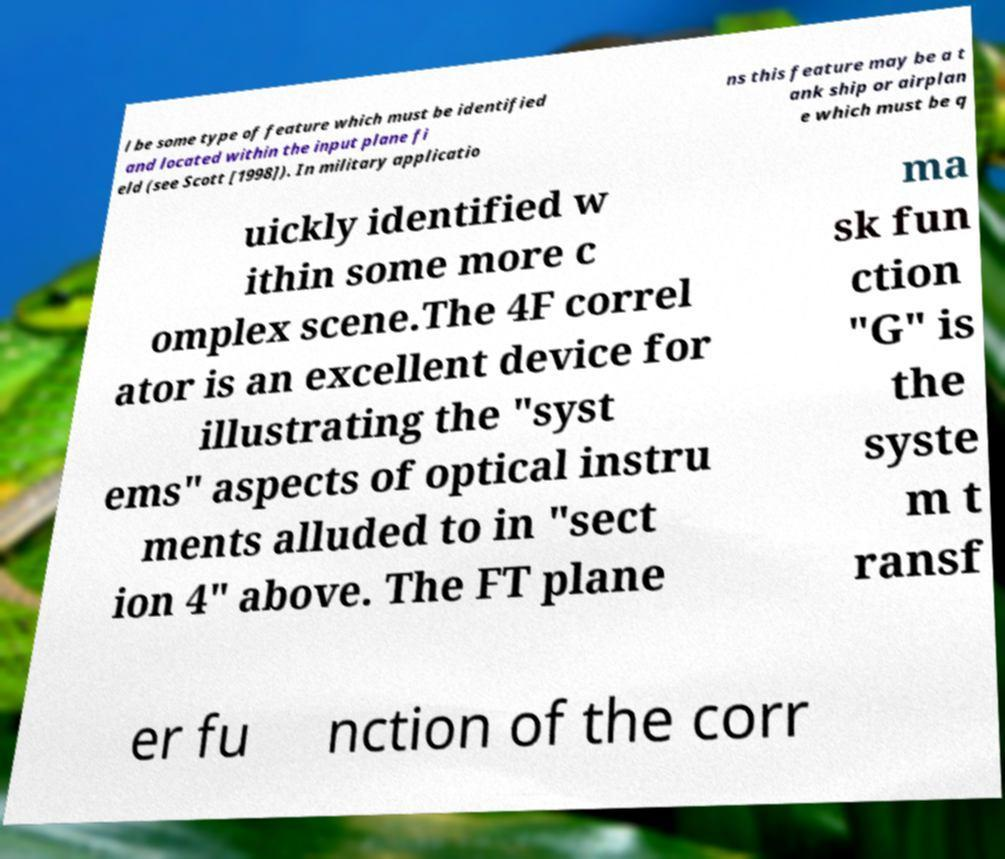Can you accurately transcribe the text from the provided image for me? l be some type of feature which must be identified and located within the input plane fi eld (see Scott [1998]). In military applicatio ns this feature may be a t ank ship or airplan e which must be q uickly identified w ithin some more c omplex scene.The 4F correl ator is an excellent device for illustrating the "syst ems" aspects of optical instru ments alluded to in "sect ion 4" above. The FT plane ma sk fun ction "G" is the syste m t ransf er fu nction of the corr 